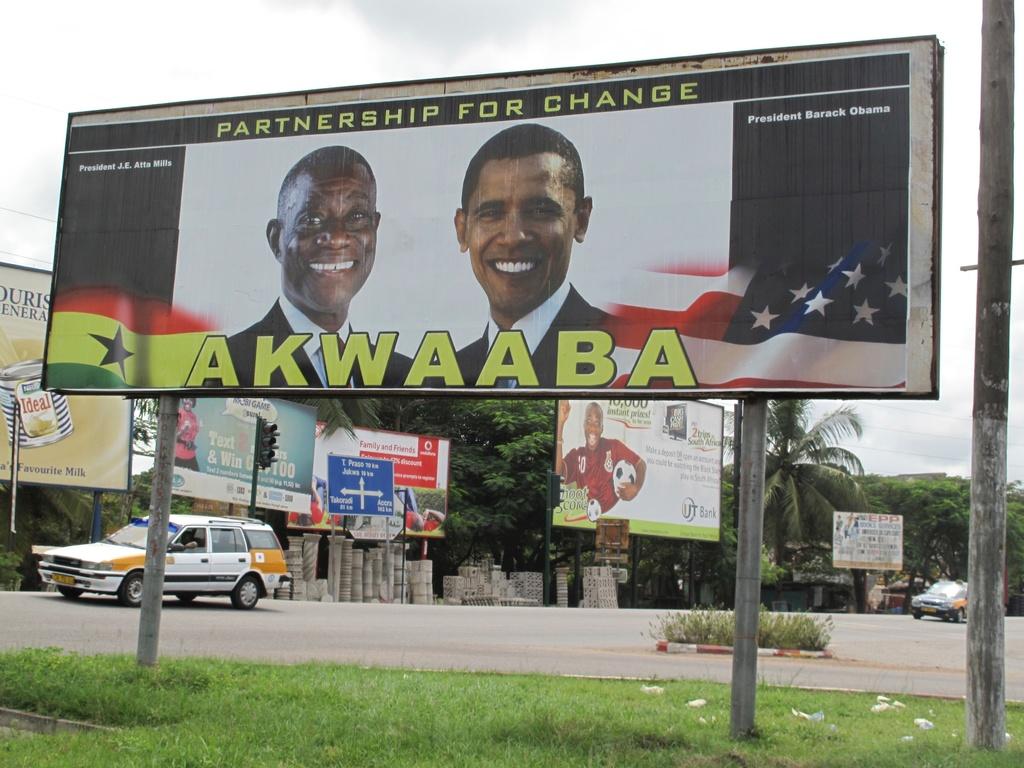Partnership for what?
Offer a terse response. Change. 